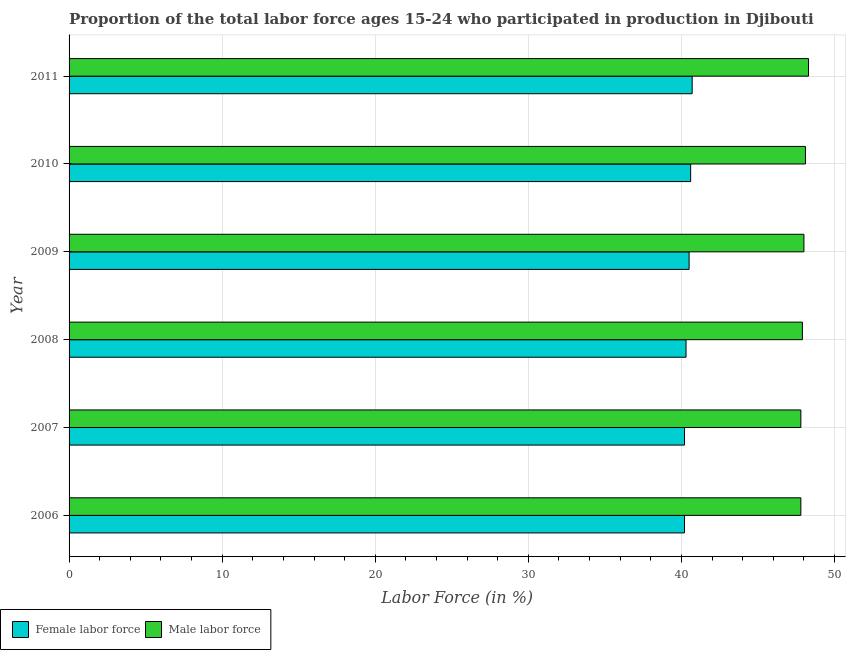How many different coloured bars are there?
Provide a succinct answer. 2. How many groups of bars are there?
Keep it short and to the point. 6. Are the number of bars per tick equal to the number of legend labels?
Provide a short and direct response. Yes. What is the label of the 6th group of bars from the top?
Make the answer very short. 2006. In how many cases, is the number of bars for a given year not equal to the number of legend labels?
Offer a very short reply. 0. What is the percentage of female labor force in 2009?
Provide a short and direct response. 40.5. Across all years, what is the maximum percentage of female labor force?
Provide a succinct answer. 40.7. Across all years, what is the minimum percentage of female labor force?
Offer a terse response. 40.2. In which year was the percentage of male labour force maximum?
Offer a terse response. 2011. In which year was the percentage of male labour force minimum?
Provide a short and direct response. 2006. What is the total percentage of male labour force in the graph?
Your response must be concise. 287.9. What is the difference between the percentage of female labor force in 2008 and the percentage of male labour force in 2010?
Keep it short and to the point. -7.8. What is the average percentage of female labor force per year?
Offer a very short reply. 40.42. In the year 2007, what is the difference between the percentage of male labour force and percentage of female labor force?
Your response must be concise. 7.6. Is the percentage of male labour force in 2007 less than that in 2011?
Give a very brief answer. Yes. What does the 2nd bar from the top in 2006 represents?
Keep it short and to the point. Female labor force. What does the 1st bar from the bottom in 2006 represents?
Give a very brief answer. Female labor force. How many bars are there?
Provide a short and direct response. 12. How many years are there in the graph?
Offer a terse response. 6. What is the difference between two consecutive major ticks on the X-axis?
Provide a short and direct response. 10. Are the values on the major ticks of X-axis written in scientific E-notation?
Provide a short and direct response. No. Where does the legend appear in the graph?
Your answer should be very brief. Bottom left. How many legend labels are there?
Offer a very short reply. 2. What is the title of the graph?
Ensure brevity in your answer.  Proportion of the total labor force ages 15-24 who participated in production in Djibouti. What is the label or title of the X-axis?
Your response must be concise. Labor Force (in %). What is the Labor Force (in %) of Female labor force in 2006?
Offer a terse response. 40.2. What is the Labor Force (in %) of Male labor force in 2006?
Make the answer very short. 47.8. What is the Labor Force (in %) of Female labor force in 2007?
Offer a terse response. 40.2. What is the Labor Force (in %) of Male labor force in 2007?
Keep it short and to the point. 47.8. What is the Labor Force (in %) in Female labor force in 2008?
Your answer should be compact. 40.3. What is the Labor Force (in %) of Male labor force in 2008?
Ensure brevity in your answer.  47.9. What is the Labor Force (in %) in Female labor force in 2009?
Provide a short and direct response. 40.5. What is the Labor Force (in %) of Female labor force in 2010?
Offer a terse response. 40.6. What is the Labor Force (in %) of Male labor force in 2010?
Offer a terse response. 48.1. What is the Labor Force (in %) in Female labor force in 2011?
Make the answer very short. 40.7. What is the Labor Force (in %) of Male labor force in 2011?
Give a very brief answer. 48.3. Across all years, what is the maximum Labor Force (in %) of Female labor force?
Make the answer very short. 40.7. Across all years, what is the maximum Labor Force (in %) in Male labor force?
Keep it short and to the point. 48.3. Across all years, what is the minimum Labor Force (in %) of Female labor force?
Offer a very short reply. 40.2. Across all years, what is the minimum Labor Force (in %) of Male labor force?
Offer a terse response. 47.8. What is the total Labor Force (in %) of Female labor force in the graph?
Make the answer very short. 242.5. What is the total Labor Force (in %) in Male labor force in the graph?
Ensure brevity in your answer.  287.9. What is the difference between the Labor Force (in %) in Male labor force in 2006 and that in 2008?
Your answer should be compact. -0.1. What is the difference between the Labor Force (in %) in Female labor force in 2006 and that in 2009?
Make the answer very short. -0.3. What is the difference between the Labor Force (in %) in Male labor force in 2006 and that in 2010?
Your answer should be very brief. -0.3. What is the difference between the Labor Force (in %) of Female labor force in 2006 and that in 2011?
Give a very brief answer. -0.5. What is the difference between the Labor Force (in %) in Male labor force in 2006 and that in 2011?
Make the answer very short. -0.5. What is the difference between the Labor Force (in %) in Male labor force in 2007 and that in 2009?
Make the answer very short. -0.2. What is the difference between the Labor Force (in %) in Male labor force in 2007 and that in 2010?
Keep it short and to the point. -0.3. What is the difference between the Labor Force (in %) in Male labor force in 2007 and that in 2011?
Your answer should be very brief. -0.5. What is the difference between the Labor Force (in %) in Female labor force in 2008 and that in 2010?
Give a very brief answer. -0.3. What is the difference between the Labor Force (in %) of Female labor force in 2008 and that in 2011?
Ensure brevity in your answer.  -0.4. What is the difference between the Labor Force (in %) in Male labor force in 2008 and that in 2011?
Give a very brief answer. -0.4. What is the difference between the Labor Force (in %) of Male labor force in 2009 and that in 2010?
Your response must be concise. -0.1. What is the difference between the Labor Force (in %) of Female labor force in 2009 and that in 2011?
Your answer should be compact. -0.2. What is the difference between the Labor Force (in %) of Male labor force in 2009 and that in 2011?
Give a very brief answer. -0.3. What is the difference between the Labor Force (in %) of Female labor force in 2006 and the Labor Force (in %) of Male labor force in 2009?
Your response must be concise. -7.8. What is the difference between the Labor Force (in %) of Female labor force in 2006 and the Labor Force (in %) of Male labor force in 2011?
Keep it short and to the point. -8.1. What is the difference between the Labor Force (in %) in Female labor force in 2007 and the Labor Force (in %) in Male labor force in 2009?
Provide a succinct answer. -7.8. What is the difference between the Labor Force (in %) of Female labor force in 2007 and the Labor Force (in %) of Male labor force in 2010?
Provide a short and direct response. -7.9. What is the difference between the Labor Force (in %) of Female labor force in 2007 and the Labor Force (in %) of Male labor force in 2011?
Keep it short and to the point. -8.1. What is the difference between the Labor Force (in %) in Female labor force in 2008 and the Labor Force (in %) in Male labor force in 2009?
Give a very brief answer. -7.7. What is the difference between the Labor Force (in %) in Female labor force in 2008 and the Labor Force (in %) in Male labor force in 2010?
Your response must be concise. -7.8. What is the difference between the Labor Force (in %) of Female labor force in 2008 and the Labor Force (in %) of Male labor force in 2011?
Your answer should be compact. -8. What is the difference between the Labor Force (in %) of Female labor force in 2009 and the Labor Force (in %) of Male labor force in 2011?
Ensure brevity in your answer.  -7.8. What is the difference between the Labor Force (in %) in Female labor force in 2010 and the Labor Force (in %) in Male labor force in 2011?
Keep it short and to the point. -7.7. What is the average Labor Force (in %) in Female labor force per year?
Keep it short and to the point. 40.42. What is the average Labor Force (in %) in Male labor force per year?
Make the answer very short. 47.98. In the year 2006, what is the difference between the Labor Force (in %) in Female labor force and Labor Force (in %) in Male labor force?
Provide a short and direct response. -7.6. In the year 2007, what is the difference between the Labor Force (in %) in Female labor force and Labor Force (in %) in Male labor force?
Your response must be concise. -7.6. In the year 2009, what is the difference between the Labor Force (in %) of Female labor force and Labor Force (in %) of Male labor force?
Give a very brief answer. -7.5. In the year 2010, what is the difference between the Labor Force (in %) in Female labor force and Labor Force (in %) in Male labor force?
Your response must be concise. -7.5. In the year 2011, what is the difference between the Labor Force (in %) in Female labor force and Labor Force (in %) in Male labor force?
Make the answer very short. -7.6. What is the ratio of the Labor Force (in %) in Female labor force in 2006 to that in 2007?
Make the answer very short. 1. What is the ratio of the Labor Force (in %) in Female labor force in 2006 to that in 2008?
Keep it short and to the point. 1. What is the ratio of the Labor Force (in %) in Female labor force in 2006 to that in 2009?
Your answer should be compact. 0.99. What is the ratio of the Labor Force (in %) in Female labor force in 2006 to that in 2010?
Provide a succinct answer. 0.99. What is the ratio of the Labor Force (in %) of Male labor force in 2006 to that in 2010?
Offer a terse response. 0.99. What is the ratio of the Labor Force (in %) of Male labor force in 2006 to that in 2011?
Provide a short and direct response. 0.99. What is the ratio of the Labor Force (in %) of Female labor force in 2007 to that in 2009?
Provide a succinct answer. 0.99. What is the ratio of the Labor Force (in %) in Male labor force in 2007 to that in 2009?
Provide a succinct answer. 1. What is the ratio of the Labor Force (in %) in Female labor force in 2007 to that in 2010?
Your answer should be compact. 0.99. What is the ratio of the Labor Force (in %) of Female labor force in 2008 to that in 2009?
Your answer should be compact. 1. What is the ratio of the Labor Force (in %) in Male labor force in 2008 to that in 2009?
Provide a short and direct response. 1. What is the ratio of the Labor Force (in %) in Female labor force in 2008 to that in 2011?
Offer a very short reply. 0.99. What is the ratio of the Labor Force (in %) of Female labor force in 2009 to that in 2010?
Give a very brief answer. 1. What is the ratio of the Labor Force (in %) of Male labor force in 2009 to that in 2010?
Your answer should be compact. 1. What is the ratio of the Labor Force (in %) in Female labor force in 2009 to that in 2011?
Offer a very short reply. 1. What is the ratio of the Labor Force (in %) in Female labor force in 2010 to that in 2011?
Ensure brevity in your answer.  1. What is the difference between the highest and the second highest Labor Force (in %) in Female labor force?
Provide a succinct answer. 0.1. What is the difference between the highest and the lowest Labor Force (in %) of Female labor force?
Keep it short and to the point. 0.5. What is the difference between the highest and the lowest Labor Force (in %) of Male labor force?
Offer a very short reply. 0.5. 